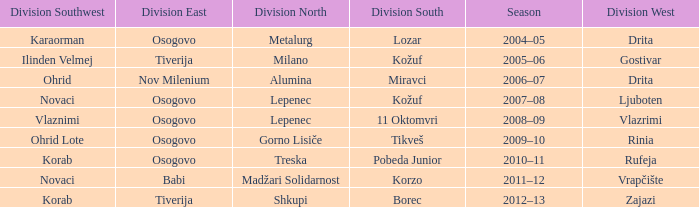Who won Division Southwest when Madžari Solidarnost won Division North? Novaci. 